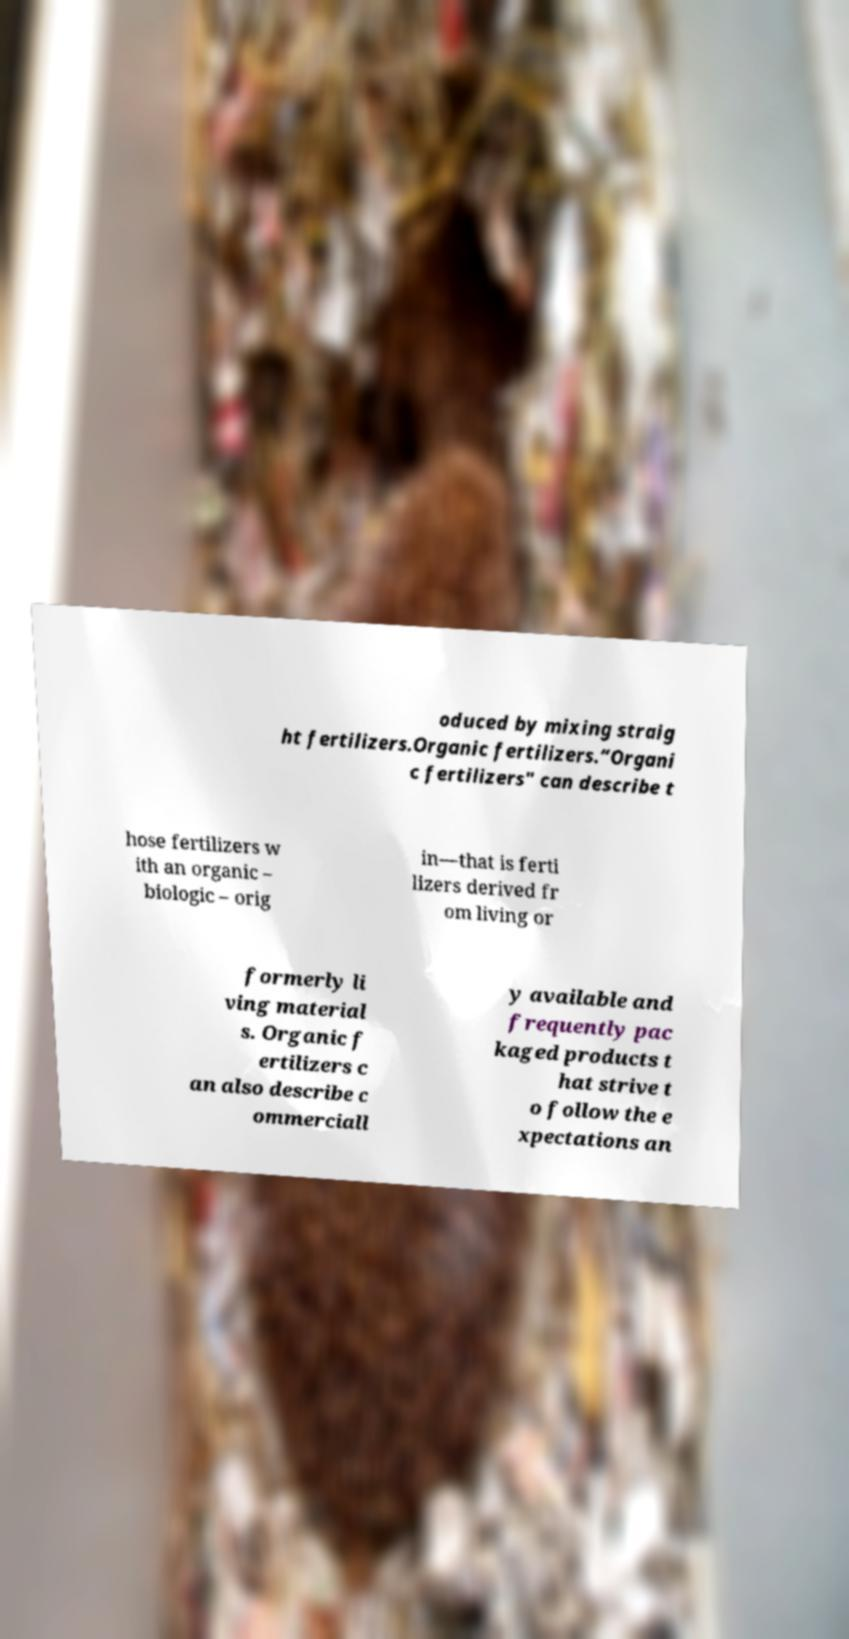There's text embedded in this image that I need extracted. Can you transcribe it verbatim? oduced by mixing straig ht fertilizers.Organic fertilizers.“Organi c fertilizers" can describe t hose fertilizers w ith an organic – biologic – orig in—that is ferti lizers derived fr om living or formerly li ving material s. Organic f ertilizers c an also describe c ommerciall y available and frequently pac kaged products t hat strive t o follow the e xpectations an 